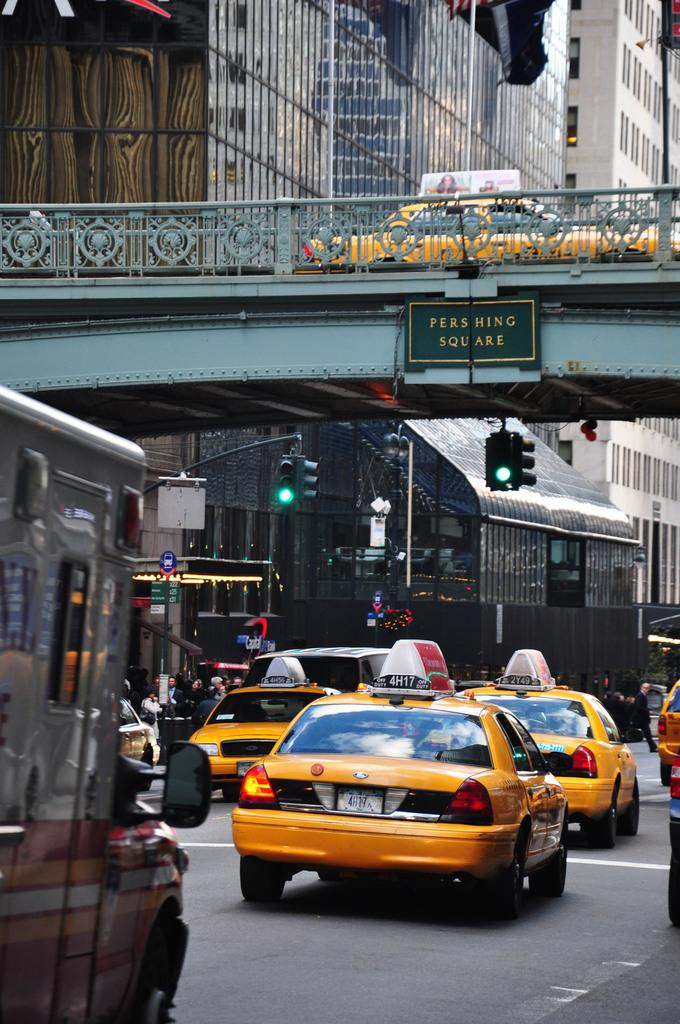<image>
Give a short and clear explanation of the subsequent image. A bunch of cars drive under and above pershing square. 